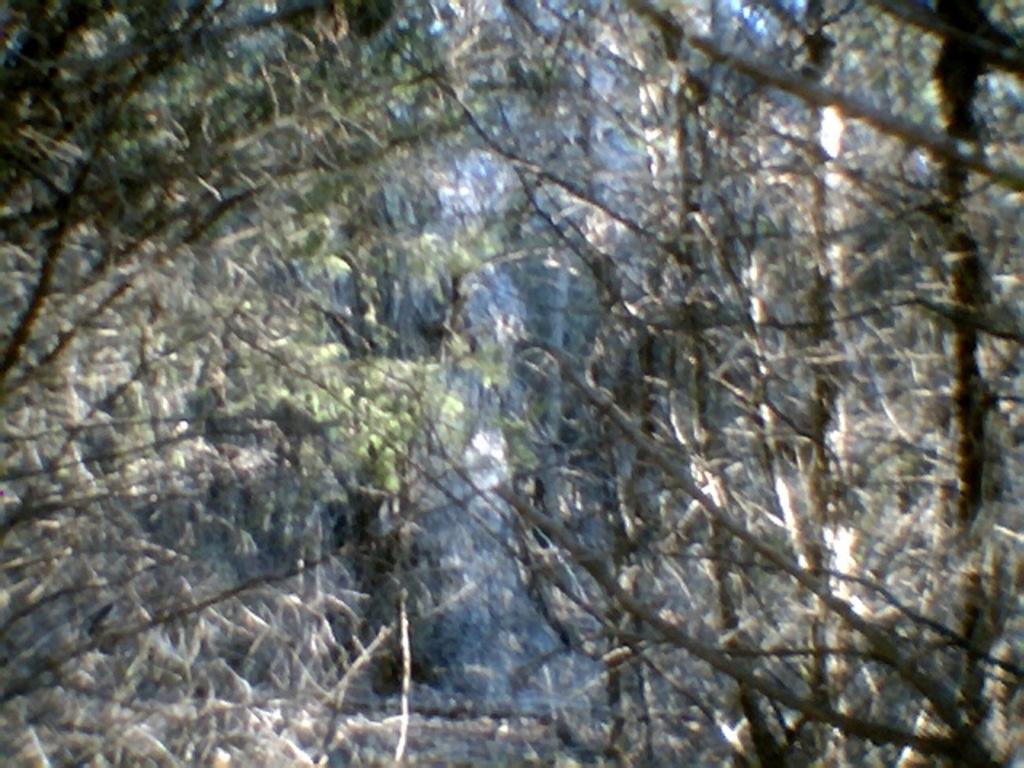Could you give a brief overview of what you see in this image? In this picture there are trees. 